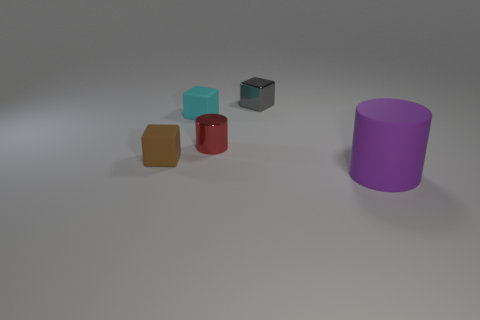What size is the red cylinder?
Offer a terse response. Small. Are there fewer gray metallic blocks in front of the red thing than purple rubber cylinders?
Your answer should be very brief. Yes. Is the material of the red thing the same as the cylinder on the right side of the gray object?
Give a very brief answer. No. Is there a gray object on the left side of the tiny thing that is on the left side of the tiny matte cube on the right side of the brown rubber object?
Offer a very short reply. No. Is there anything else that has the same size as the brown rubber object?
Offer a very short reply. Yes. What color is the tiny object that is made of the same material as the tiny red cylinder?
Offer a terse response. Gray. How big is the rubber thing that is on the left side of the big purple cylinder and right of the tiny brown rubber object?
Your answer should be very brief. Small. Are there fewer cyan objects that are behind the small gray metal block than red shiny cylinders to the left of the tiny brown cube?
Offer a terse response. No. Is the small cube in front of the small metallic cylinder made of the same material as the cylinder that is in front of the tiny red thing?
Ensure brevity in your answer.  Yes. The small thing that is both behind the red thing and in front of the tiny metallic block has what shape?
Ensure brevity in your answer.  Cube. 